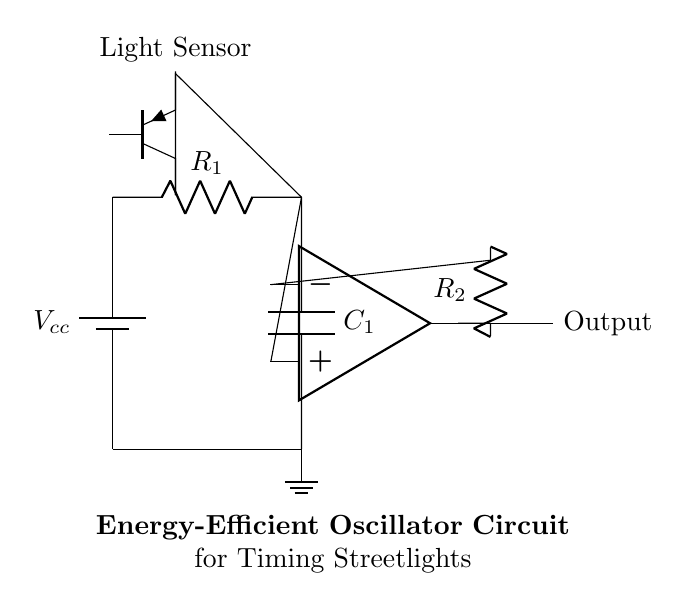What type of circuit is depicted? The circuit illustrates an oscillator, which generates a periodic signal used for timing applications. The components and configuration indicate its purpose in controlling streetlights.
Answer: oscillator What is the primary power supply voltage? The voltage shown is Vcc, which represents the main voltage supply for the circuit. This value typically powers the entire circuit, although the specific number isn’t provided here.
Answer: Vcc How many resistors are in the circuit? There are two resistors labeled R1 and R2 in the circuit diagram. They are essential for controlling current and setting timing intervals within the oscillator.
Answer: two Which component is responsible for sensing light? The component that detects light in the circuit is a light sensor, represented by a phototransistor. Its role is to help control the oscillator based on ambient light levels.
Answer: phototransistor What role does capacitor C1 serve in this oscillator circuit? Capacitor C1 is critical for timing in the oscillator by charging and discharging, thus determining the frequency of the output signal. The resistor in combination with this capacitor forms an RC timing circuit.
Answer: timing How does the output of the circuit relate to streetlight operation? The output from the op-amp ultimately controls the timing of streetlights, turning them on or off depending on the ambient light conditions sensed by the phototransistor, thus reducing electricity costs.
Answer: controls streetlights What is the function of op-amp in this circuit? The operational amplifier (op-amp) amplifies the signal from the RC network and helps switch the output based on the timing determined by the charging and discharging of capacitor C1.
Answer: amplifies signal 